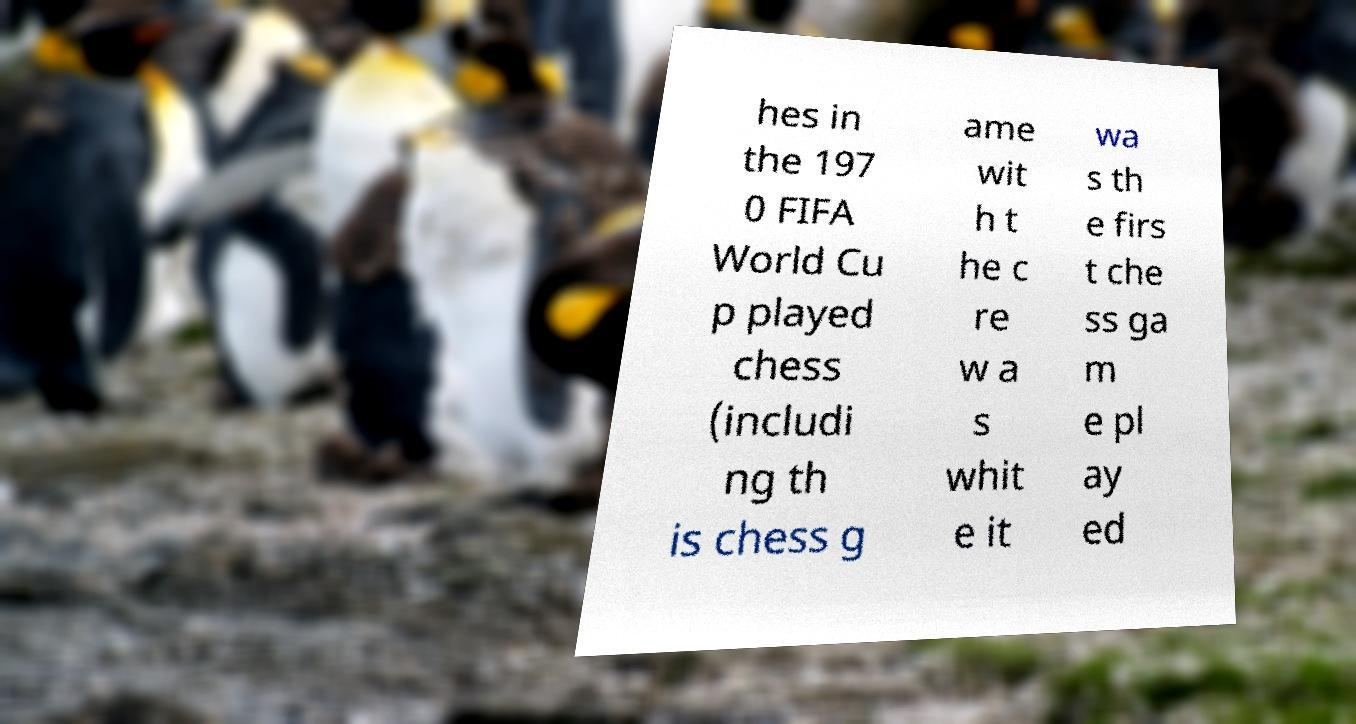Please read and relay the text visible in this image. What does it say? hes in the 197 0 FIFA World Cu p played chess (includi ng th is chess g ame wit h t he c re w a s whit e it wa s th e firs t che ss ga m e pl ay ed 